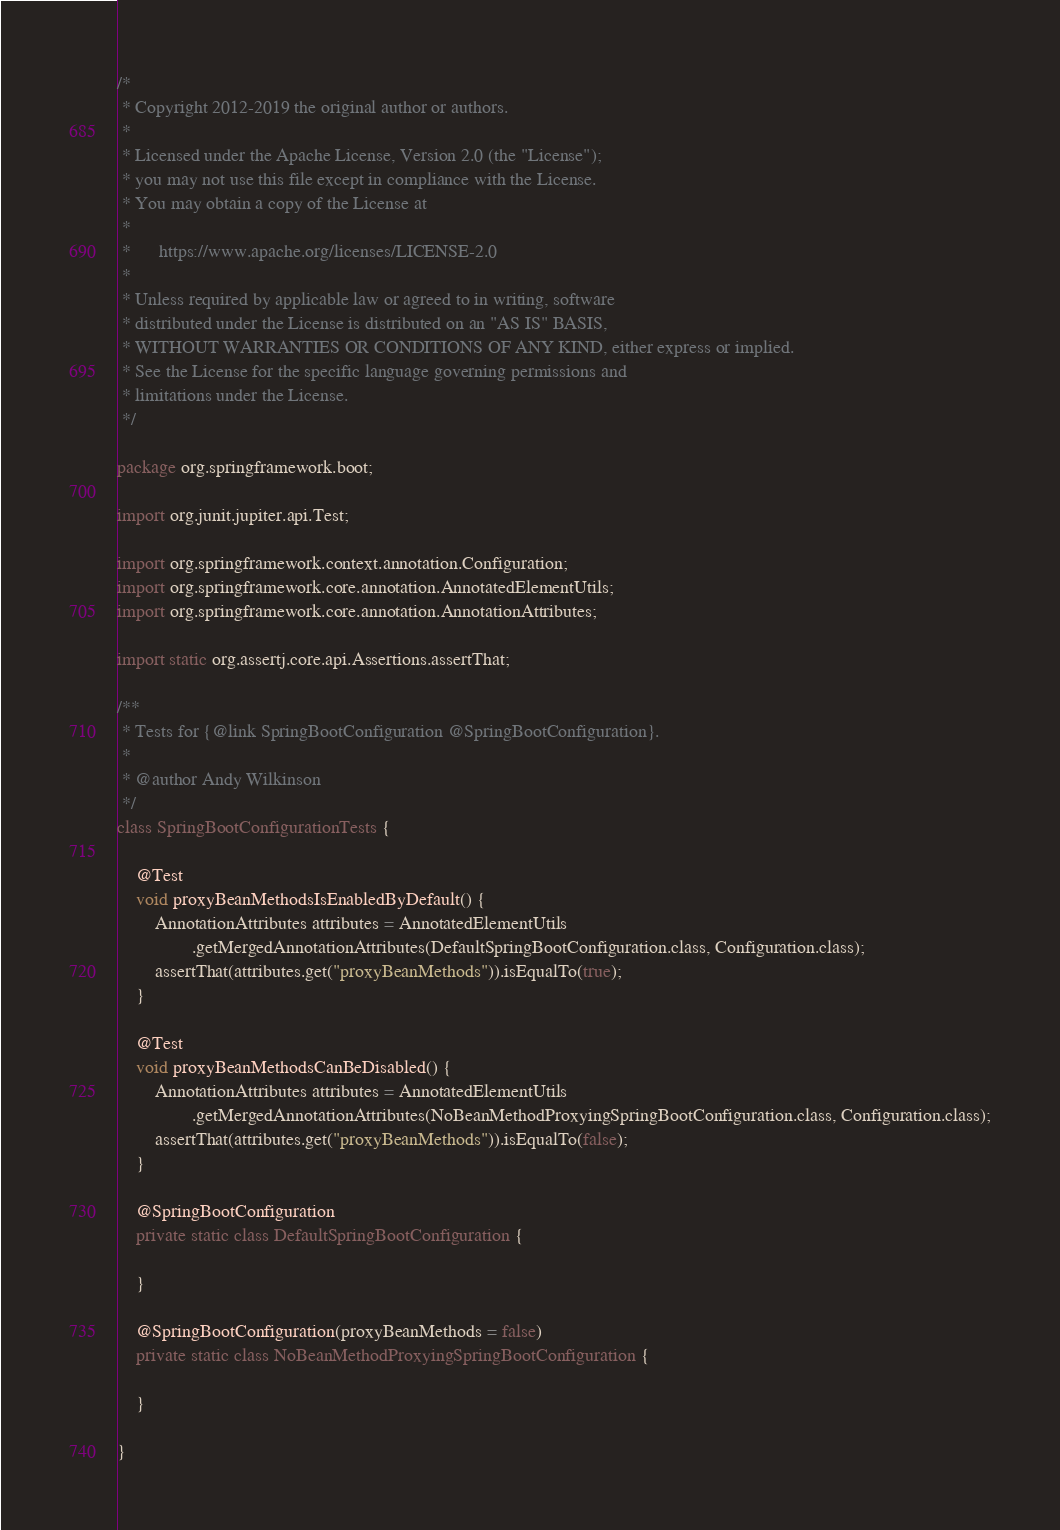<code> <loc_0><loc_0><loc_500><loc_500><_Java_>/*
 * Copyright 2012-2019 the original author or authors.
 *
 * Licensed under the Apache License, Version 2.0 (the "License");
 * you may not use this file except in compliance with the License.
 * You may obtain a copy of the License at
 *
 *      https://www.apache.org/licenses/LICENSE-2.0
 *
 * Unless required by applicable law or agreed to in writing, software
 * distributed under the License is distributed on an "AS IS" BASIS,
 * WITHOUT WARRANTIES OR CONDITIONS OF ANY KIND, either express or implied.
 * See the License for the specific language governing permissions and
 * limitations under the License.
 */

package org.springframework.boot;

import org.junit.jupiter.api.Test;

import org.springframework.context.annotation.Configuration;
import org.springframework.core.annotation.AnnotatedElementUtils;
import org.springframework.core.annotation.AnnotationAttributes;

import static org.assertj.core.api.Assertions.assertThat;

/**
 * Tests for {@link SpringBootConfiguration @SpringBootConfiguration}.
 *
 * @author Andy Wilkinson
 */
class SpringBootConfigurationTests {

	@Test
	void proxyBeanMethodsIsEnabledByDefault() {
		AnnotationAttributes attributes = AnnotatedElementUtils
				.getMergedAnnotationAttributes(DefaultSpringBootConfiguration.class, Configuration.class);
		assertThat(attributes.get("proxyBeanMethods")).isEqualTo(true);
	}

	@Test
	void proxyBeanMethodsCanBeDisabled() {
		AnnotationAttributes attributes = AnnotatedElementUtils
				.getMergedAnnotationAttributes(NoBeanMethodProxyingSpringBootConfiguration.class, Configuration.class);
		assertThat(attributes.get("proxyBeanMethods")).isEqualTo(false);
	}

	@SpringBootConfiguration
	private static class DefaultSpringBootConfiguration {

	}

	@SpringBootConfiguration(proxyBeanMethods = false)
	private static class NoBeanMethodProxyingSpringBootConfiguration {

	}

}
</code> 